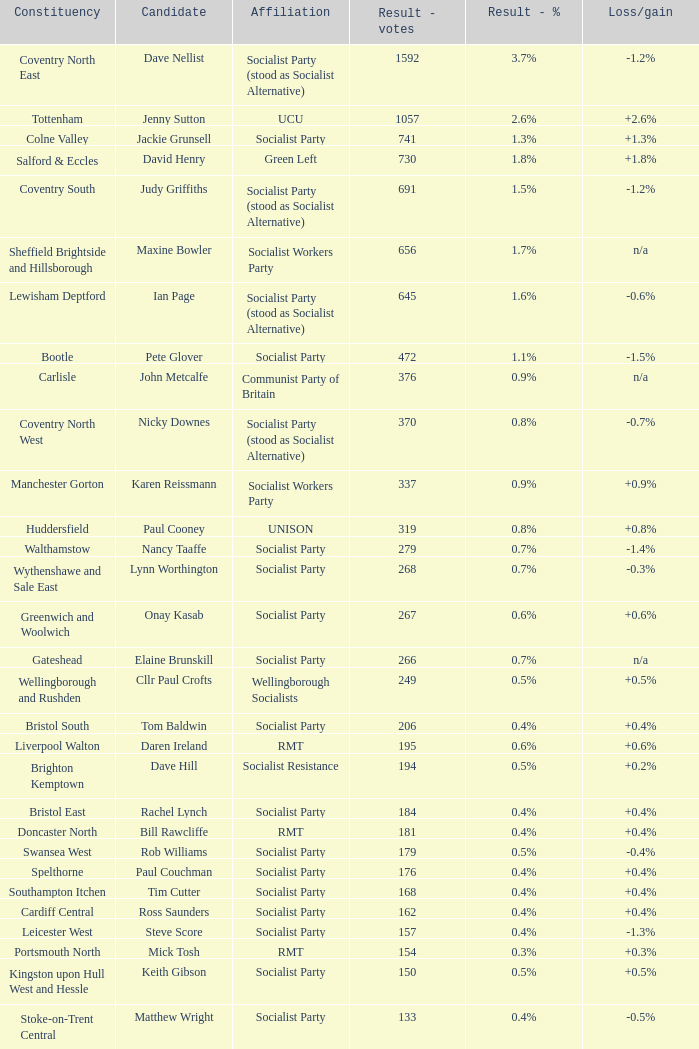What is the largest vote result if loss/gain is -0.5%? 133.0. 